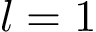<formula> <loc_0><loc_0><loc_500><loc_500>l = 1</formula> 